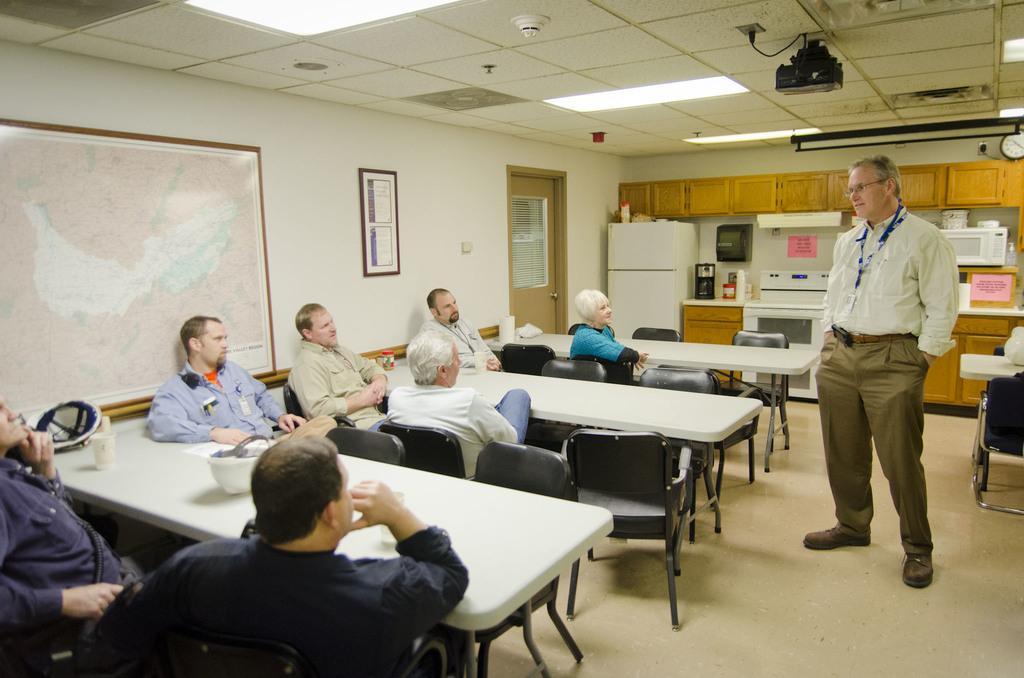Please provide a concise description of this image. In this image, group of people are sat on black chairs. There are few tables, few items are placed on it. At the background, we can see a kitchen platform, we can see microwave oven , refrigerator,few items, cupboard and a person is standing, he is talking with them. At the middle, we can see door photo frame. On left side there is a map. At roof we can see projector and lights. 